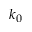Convert formula to latex. <formula><loc_0><loc_0><loc_500><loc_500>k _ { 0 }</formula> 